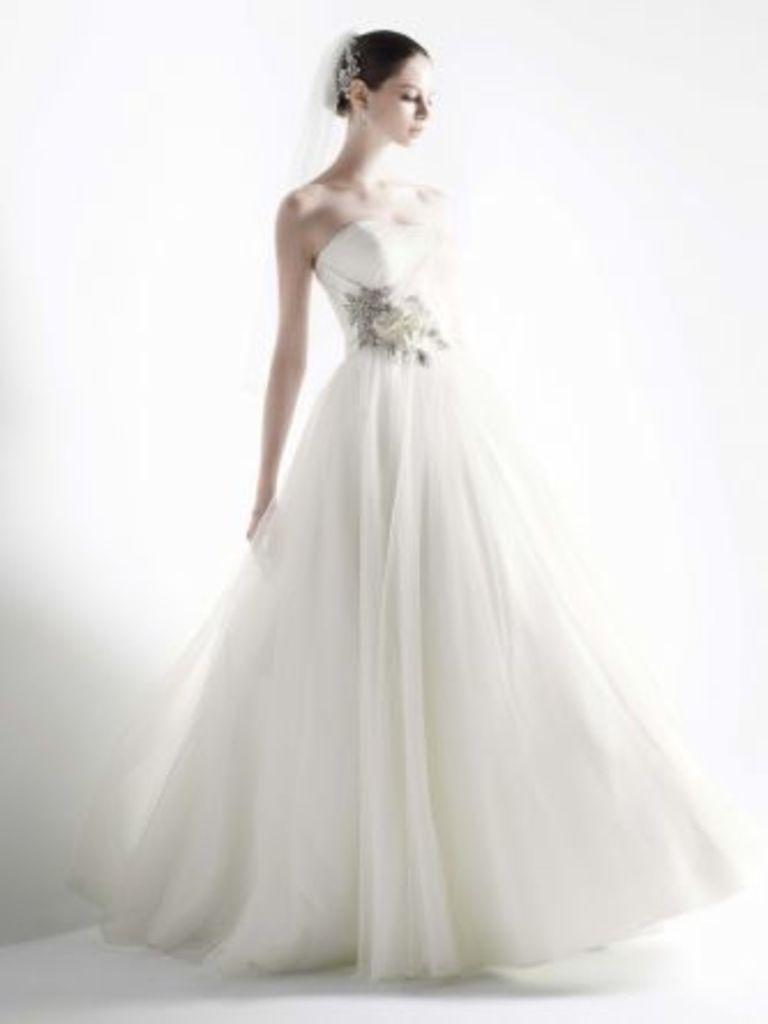What is the main subject of the image? There is a beautiful woman in the image. Can you describe the woman's attire? The woman is wearing a white dress. What is the woman's credit score in the image? There is no information about the woman's credit score in the image. What is the weight of the woman in the image? There is no information about the woman's weight in the image. 